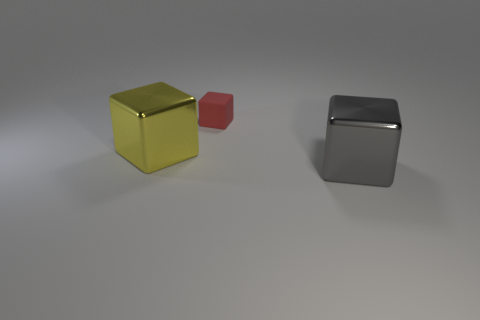Subtract all purple cubes. Subtract all yellow cylinders. How many cubes are left? 3 Add 3 small purple objects. How many objects exist? 6 Subtract 0 blue cubes. How many objects are left? 3 Subtract all gray metallic objects. Subtract all blue metal cylinders. How many objects are left? 2 Add 3 small red objects. How many small red objects are left? 4 Add 3 big yellow shiny blocks. How many big yellow shiny blocks exist? 4 